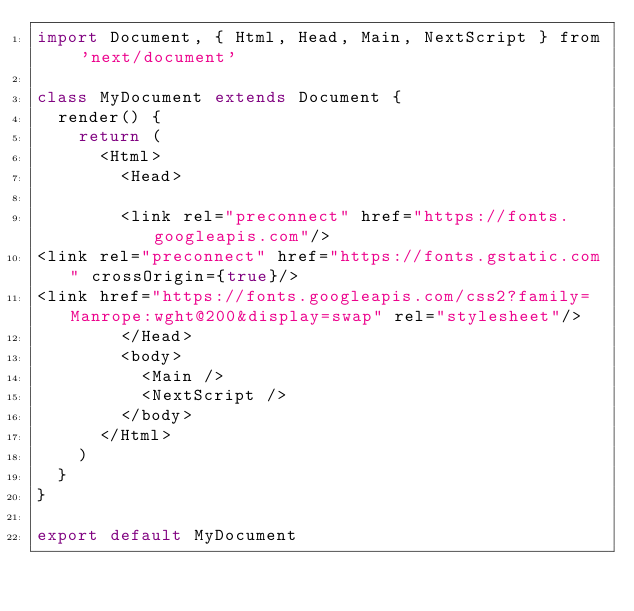Convert code to text. <code><loc_0><loc_0><loc_500><loc_500><_JavaScript_>import Document, { Html, Head, Main, NextScript } from 'next/document'

class MyDocument extends Document {
  render() {
    return (
      <Html>
        <Head>
  
        <link rel="preconnect" href="https://fonts.googleapis.com"/>
<link rel="preconnect" href="https://fonts.gstatic.com" crossOrigin={true}/>
<link href="https://fonts.googleapis.com/css2?family=Manrope:wght@200&display=swap" rel="stylesheet"/>
        </Head>
        <body>
          <Main />
          <NextScript />
        </body>
      </Html>
    )
  }
}

export default MyDocument</code> 